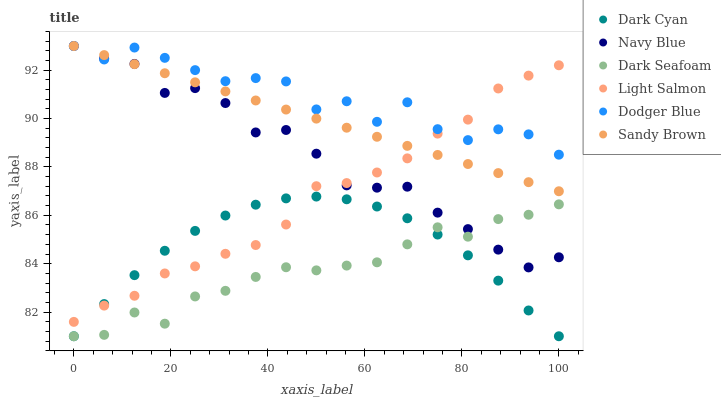Does Dark Seafoam have the minimum area under the curve?
Answer yes or no. Yes. Does Dodger Blue have the maximum area under the curve?
Answer yes or no. Yes. Does Navy Blue have the minimum area under the curve?
Answer yes or no. No. Does Navy Blue have the maximum area under the curve?
Answer yes or no. No. Is Sandy Brown the smoothest?
Answer yes or no. Yes. Is Dodger Blue the roughest?
Answer yes or no. Yes. Is Navy Blue the smoothest?
Answer yes or no. No. Is Navy Blue the roughest?
Answer yes or no. No. Does Dark Seafoam have the lowest value?
Answer yes or no. Yes. Does Navy Blue have the lowest value?
Answer yes or no. No. Does Sandy Brown have the highest value?
Answer yes or no. Yes. Does Dark Seafoam have the highest value?
Answer yes or no. No. Is Dark Seafoam less than Light Salmon?
Answer yes or no. Yes. Is Sandy Brown greater than Dark Seafoam?
Answer yes or no. Yes. Does Navy Blue intersect Light Salmon?
Answer yes or no. Yes. Is Navy Blue less than Light Salmon?
Answer yes or no. No. Is Navy Blue greater than Light Salmon?
Answer yes or no. No. Does Dark Seafoam intersect Light Salmon?
Answer yes or no. No. 